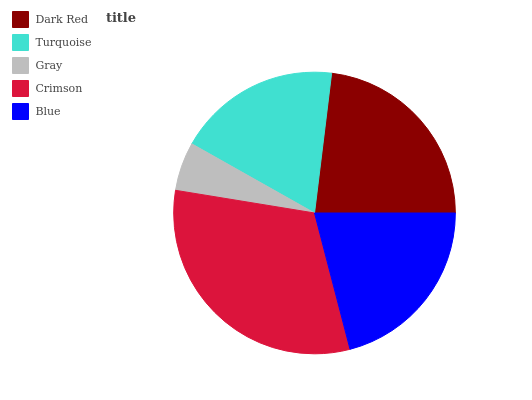Is Gray the minimum?
Answer yes or no. Yes. Is Crimson the maximum?
Answer yes or no. Yes. Is Turquoise the minimum?
Answer yes or no. No. Is Turquoise the maximum?
Answer yes or no. No. Is Dark Red greater than Turquoise?
Answer yes or no. Yes. Is Turquoise less than Dark Red?
Answer yes or no. Yes. Is Turquoise greater than Dark Red?
Answer yes or no. No. Is Dark Red less than Turquoise?
Answer yes or no. No. Is Blue the high median?
Answer yes or no. Yes. Is Blue the low median?
Answer yes or no. Yes. Is Gray the high median?
Answer yes or no. No. Is Gray the low median?
Answer yes or no. No. 